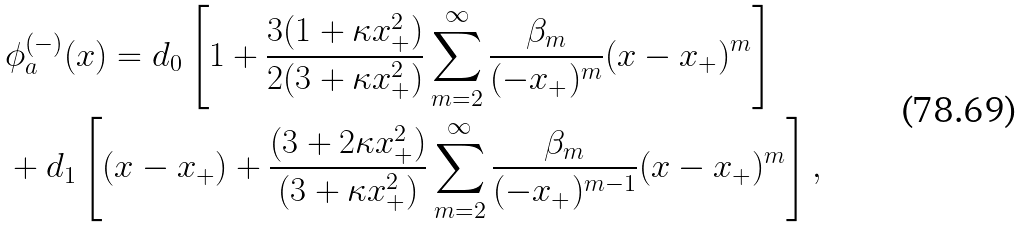Convert formula to latex. <formula><loc_0><loc_0><loc_500><loc_500>& \phi _ { a } ^ { ( - ) } ( x ) = d _ { 0 } \left [ 1 + \frac { 3 ( 1 + \kappa x _ { + } ^ { 2 } ) } { 2 ( 3 + \kappa x _ { + } ^ { 2 } ) } \sum _ { m = 2 } ^ { \infty } \frac { \beta _ { m } } { ( - x _ { + } ) ^ { m } } ( x - x _ { + } ) ^ { m } \right ] \\ & + d _ { 1 } \left [ ( x - x _ { + } ) + \frac { ( 3 + 2 \kappa x _ { + } ^ { 2 } ) } { ( 3 + \kappa x _ { + } ^ { 2 } ) } \sum _ { m = 2 } ^ { \infty } \frac { \beta _ { m } } { ( - x _ { + } ) ^ { m - 1 } } ( x - x _ { + } ) ^ { m } \right ] ,</formula> 